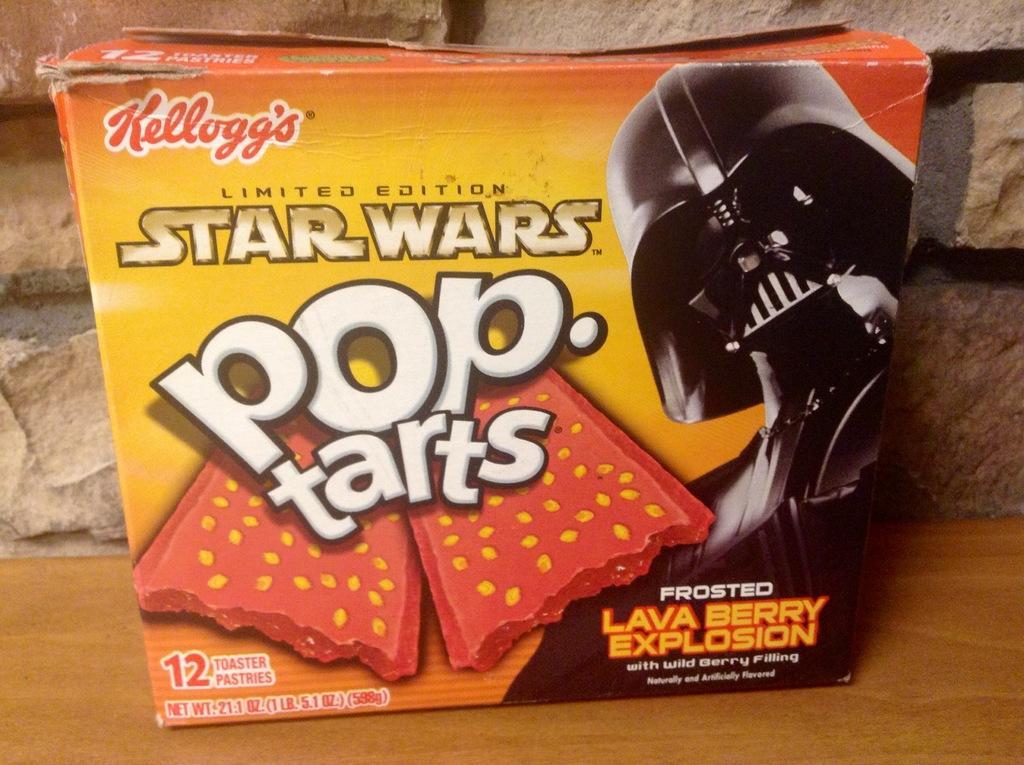Could you give a brief overview of what you see in this image? In this image we can see a box with text and image on it, which is on the wooden table, also we can see the wall. 